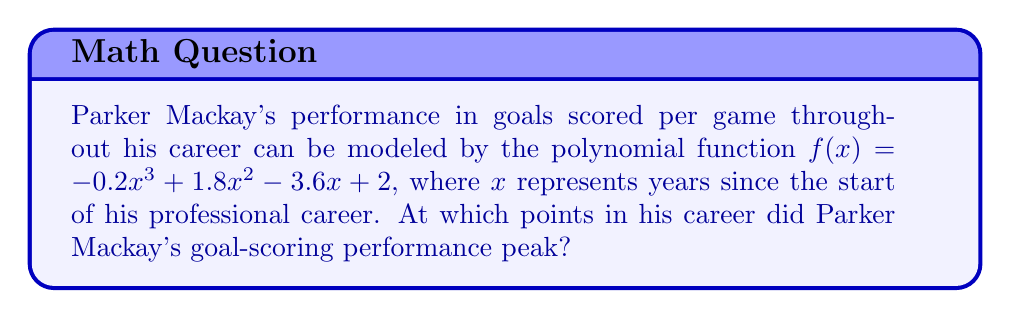Show me your answer to this math problem. To find the peak performance periods, we need to find the roots of the derivative of the given function. Here's how we can do this step-by-step:

1) First, we need to find the derivative of $f(x)$:
   $f'(x) = -0.6x^2 + 3.6x - 3.6$

2) The peaks occur where $f'(x) = 0$. So we need to solve the equation:
   $-0.6x^2 + 3.6x - 3.6 = 0$

3) This is a quadratic equation. We can solve it using the quadratic formula:
   $x = \frac{-b \pm \sqrt{b^2 - 4ac}}{2a}$

   Where $a = -0.6$, $b = 3.6$, and $c = -3.6$

4) Substituting these values:
   $x = \frac{-3.6 \pm \sqrt{3.6^2 - 4(-0.6)(-3.6)}}{2(-0.6)}$

5) Simplifying:
   $x = \frac{-3.6 \pm \sqrt{12.96 - 8.64}}{-1.2}$
   $x = \frac{-3.6 \pm \sqrt{4.32}}{-1.2}$
   $x = \frac{-3.6 \pm 2.08}{-1.2}$

6) This gives us two solutions:
   $x_1 = \frac{-3.6 + 2.08}{-1.2} = 1.27$
   $x_2 = \frac{-3.6 - 2.08}{-1.2} = 4.73$

Therefore, Parker Mackay's goal-scoring performance peaked at approximately 1.27 years and 4.73 years into his professional career.
Answer: 1.27 years and 4.73 years into his career 